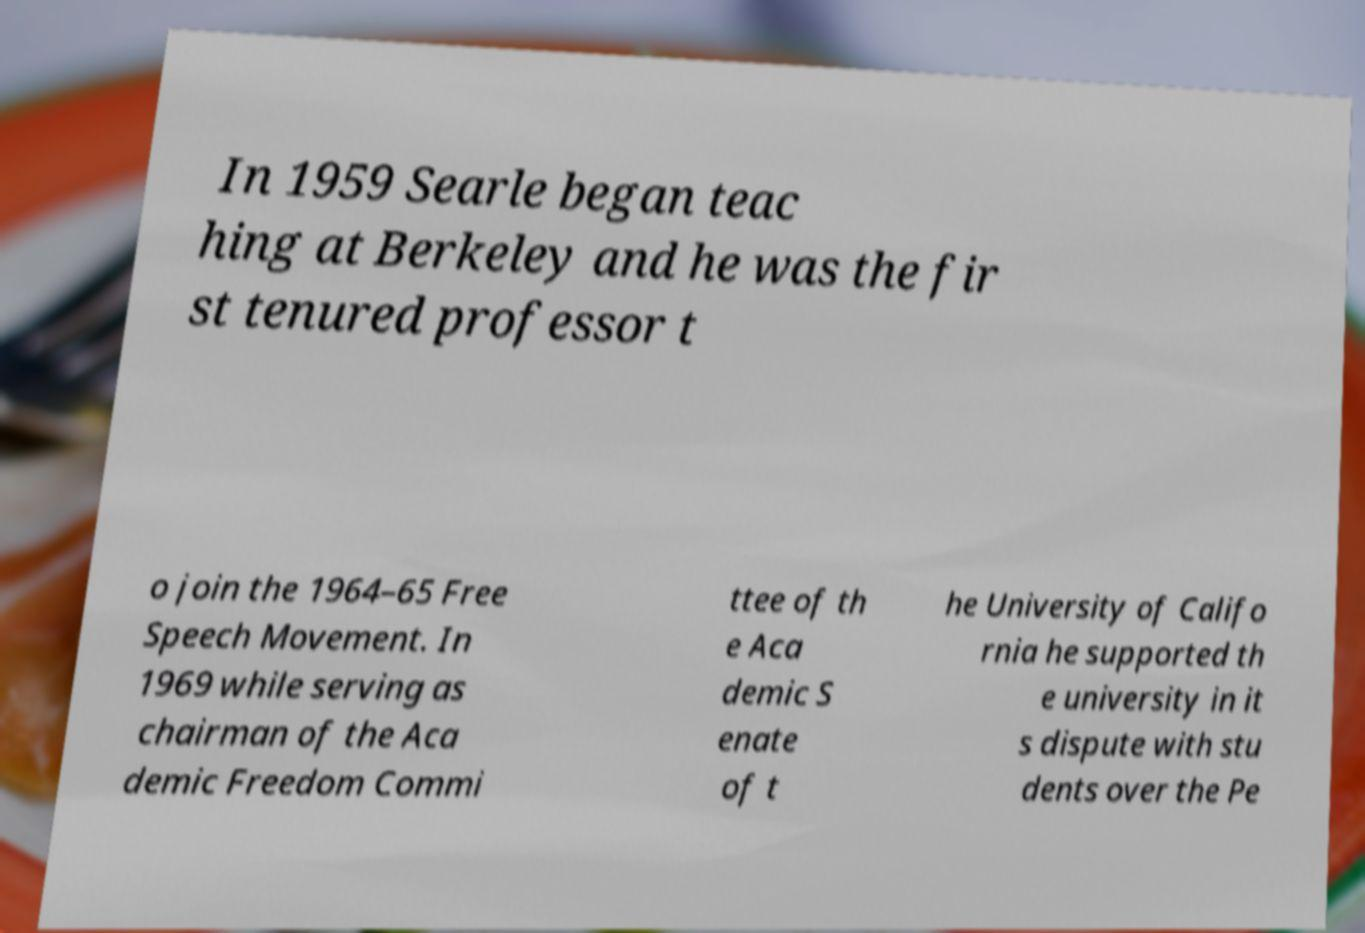Please identify and transcribe the text found in this image. In 1959 Searle began teac hing at Berkeley and he was the fir st tenured professor t o join the 1964–65 Free Speech Movement. In 1969 while serving as chairman of the Aca demic Freedom Commi ttee of th e Aca demic S enate of t he University of Califo rnia he supported th e university in it s dispute with stu dents over the Pe 